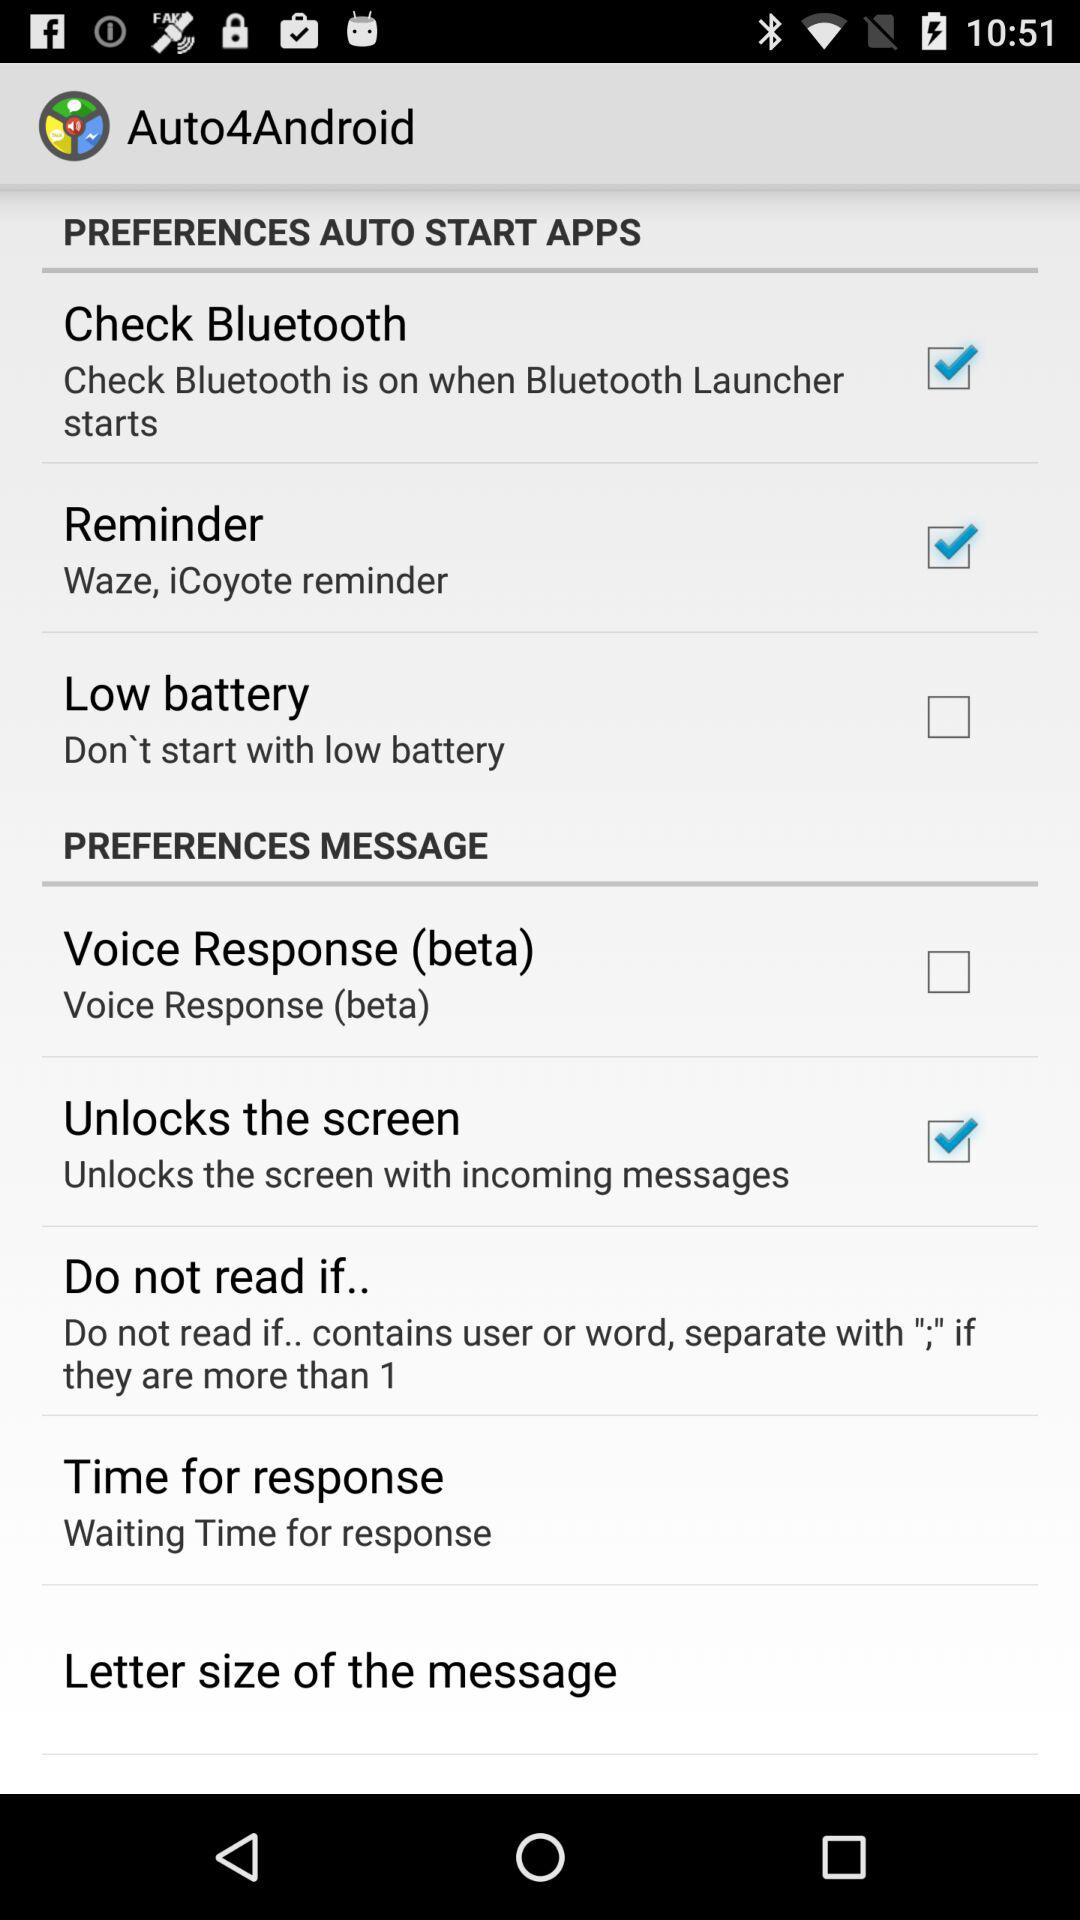How many items are there in the Message section?
Answer the question using a single word or phrase. 5 